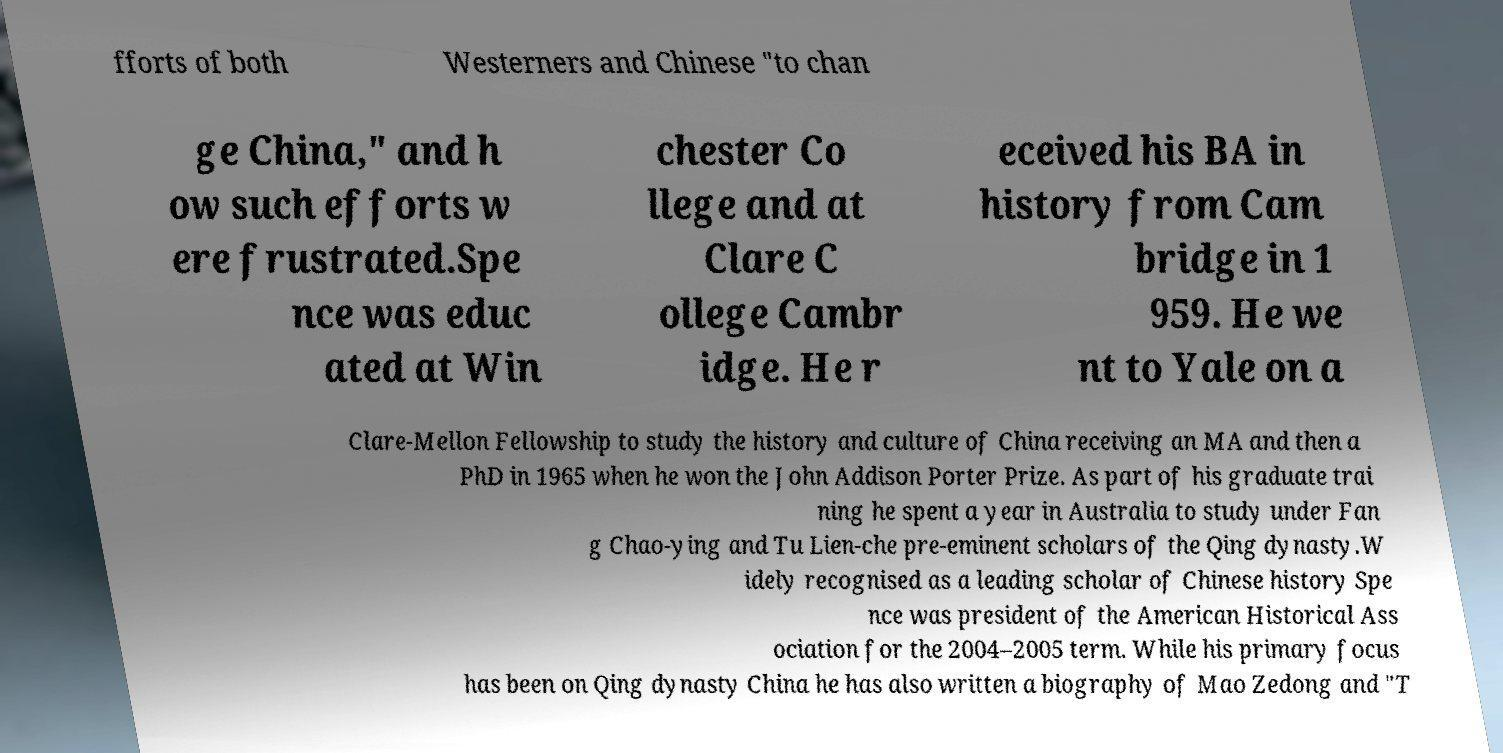I need the written content from this picture converted into text. Can you do that? fforts of both Westerners and Chinese "to chan ge China," and h ow such efforts w ere frustrated.Spe nce was educ ated at Win chester Co llege and at Clare C ollege Cambr idge. He r eceived his BA in history from Cam bridge in 1 959. He we nt to Yale on a Clare-Mellon Fellowship to study the history and culture of China receiving an MA and then a PhD in 1965 when he won the John Addison Porter Prize. As part of his graduate trai ning he spent a year in Australia to study under Fan g Chao-ying and Tu Lien-che pre-eminent scholars of the Qing dynasty.W idely recognised as a leading scholar of Chinese history Spe nce was president of the American Historical Ass ociation for the 2004–2005 term. While his primary focus has been on Qing dynasty China he has also written a biography of Mao Zedong and "T 